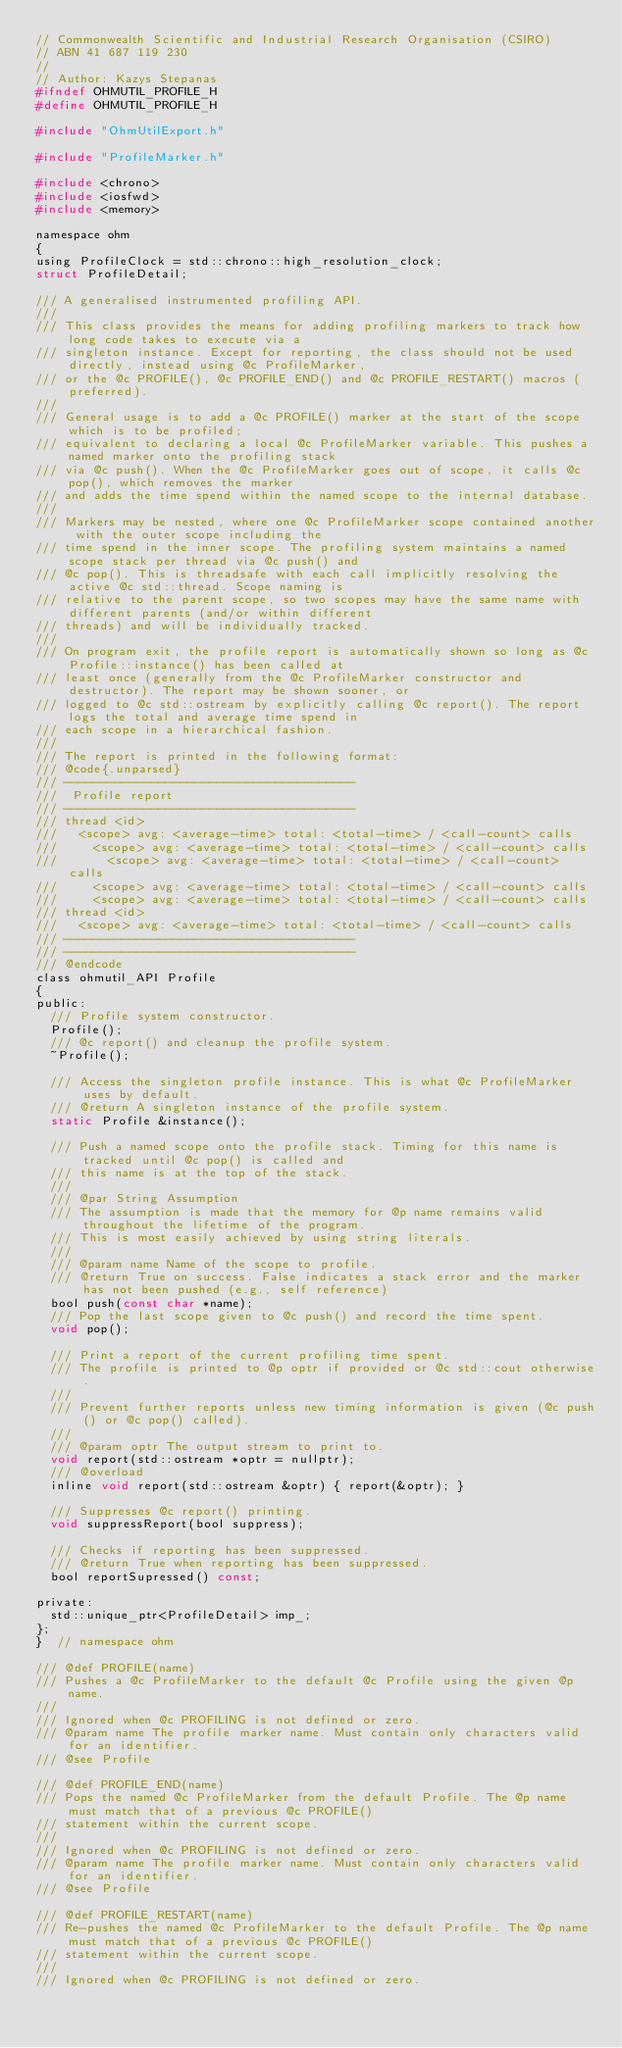Convert code to text. <code><loc_0><loc_0><loc_500><loc_500><_C_>// Commonwealth Scientific and Industrial Research Organisation (CSIRO)
// ABN 41 687 119 230
//
// Author: Kazys Stepanas
#ifndef OHMUTIL_PROFILE_H
#define OHMUTIL_PROFILE_H

#include "OhmUtilExport.h"

#include "ProfileMarker.h"

#include <chrono>
#include <iosfwd>
#include <memory>

namespace ohm
{
using ProfileClock = std::chrono::high_resolution_clock;
struct ProfileDetail;

/// A generalised instrumented profiling API.
///
/// This class provides the means for adding profiling markers to track how long code takes to execute via a
/// singleton instance. Except for reporting, the class should not be used directly, instead using @c ProfileMarker,
/// or the @c PROFILE(), @c PROFILE_END() and @c PROFILE_RESTART() macros (preferred).
///
/// General usage is to add a @c PROFILE() marker at the start of the scope which is to be profiled;
/// equivalent to declaring a local @c ProfileMarker variable. This pushes a named marker onto the profiling stack
/// via @c push(). When the @c ProfileMarker goes out of scope, it calls @c pop(), which removes the marker
/// and adds the time spend within the named scope to the internal database.
///
/// Markers may be nested, where one @c ProfileMarker scope contained another with the outer scope including the
/// time spend in the inner scope. The profiling system maintains a named scope stack per thread via @c push() and
/// @c pop(). This is threadsafe with each call implicitly resolving the active @c std::thread. Scope naming is
/// relative to the parent scope, so two scopes may have the same name with different parents (and/or within different
/// threads) and will be individually tracked.
///
/// On program exit, the profile report is automatically shown so long as @c Profile::instance() has been called at
/// least once (generally from the @c ProfileMarker constructor and destructor). The report may be shown sooner, or
/// logged to @c std::ostream by explicitly calling @c report(). The report logs the total and average time spend in
/// each scope in a hierarchical fashion.
///
/// The report is printed in the following format:
/// @code{.unparsed}
/// ----------------------------------------
///  Profile report
/// ----------------------------------------
/// thread <id>
///   <scope> avg: <average-time> total: <total-time> / <call-count> calls
///     <scope> avg: <average-time> total: <total-time> / <call-count> calls
///       <scope> avg: <average-time> total: <total-time> / <call-count> calls
///     <scope> avg: <average-time> total: <total-time> / <call-count> calls
///     <scope> avg: <average-time> total: <total-time> / <call-count> calls
/// thread <id>
///   <scope> avg: <average-time> total: <total-time> / <call-count> calls
/// ----------------------------------------
/// ----------------------------------------
/// @endcode
class ohmutil_API Profile
{
public:
  /// Profile system constructor.
  Profile();
  /// @c report() and cleanup the profile system.
  ~Profile();

  /// Access the singleton profile instance. This is what @c ProfileMarker uses by default.
  /// @return A singleton instance of the profile system.
  static Profile &instance();

  /// Push a named scope onto the profile stack. Timing for this name is tracked until @c pop() is called and
  /// this name is at the top of the stack.
  ///
  /// @par String Assumption
  /// The assumption is made that the memory for @p name remains valid throughout the lifetime of the program.
  /// This is most easily achieved by using string literals.
  ///
  /// @param name Name of the scope to profile.
  /// @return True on success. False indicates a stack error and the marker has not been pushed (e.g., self reference)
  bool push(const char *name);
  /// Pop the last scope given to @c push() and record the time spent.
  void pop();

  /// Print a report of the current profiling time spent.
  /// The profile is printed to @p optr if provided or @c std::cout otherwise.
  ///
  /// Prevent further reports unless new timing information is given (@c push() or @c pop() called).
  ///
  /// @param optr The output stream to print to.
  void report(std::ostream *optr = nullptr);
  /// @overload
  inline void report(std::ostream &optr) { report(&optr); }

  /// Suppresses @c report() printing.
  void suppressReport(bool suppress);

  /// Checks if reporting has been suppressed.
  /// @return True when reporting has been suppressed.
  bool reportSupressed() const;

private:
  std::unique_ptr<ProfileDetail> imp_;
};
}  // namespace ohm

/// @def PROFILE(name)
/// Pushes a @c ProfileMarker to the default @c Profile using the given @p name.
///
/// Ignored when @c PROFILING is not defined or zero.
/// @param name The profile marker name. Must contain only characters valid for an identifier.
/// @see Profile

/// @def PROFILE_END(name)
/// Pops the named @c ProfileMarker from the default Profile. The @p name must match that of a previous @c PROFILE()
/// statement within the current scope.
///
/// Ignored when @c PROFILING is not defined or zero.
/// @param name The profile marker name. Must contain only characters valid for an identifier.
/// @see Profile

/// @def PROFILE_RESTART(name)
/// Re-pushes the named @c ProfileMarker to the default Profile. The @p name must match that of a previous @c PROFILE()
/// statement within the current scope.
///
/// Ignored when @c PROFILING is not defined or zero.</code> 